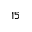<formula> <loc_0><loc_0><loc_500><loc_500>1 5</formula> 